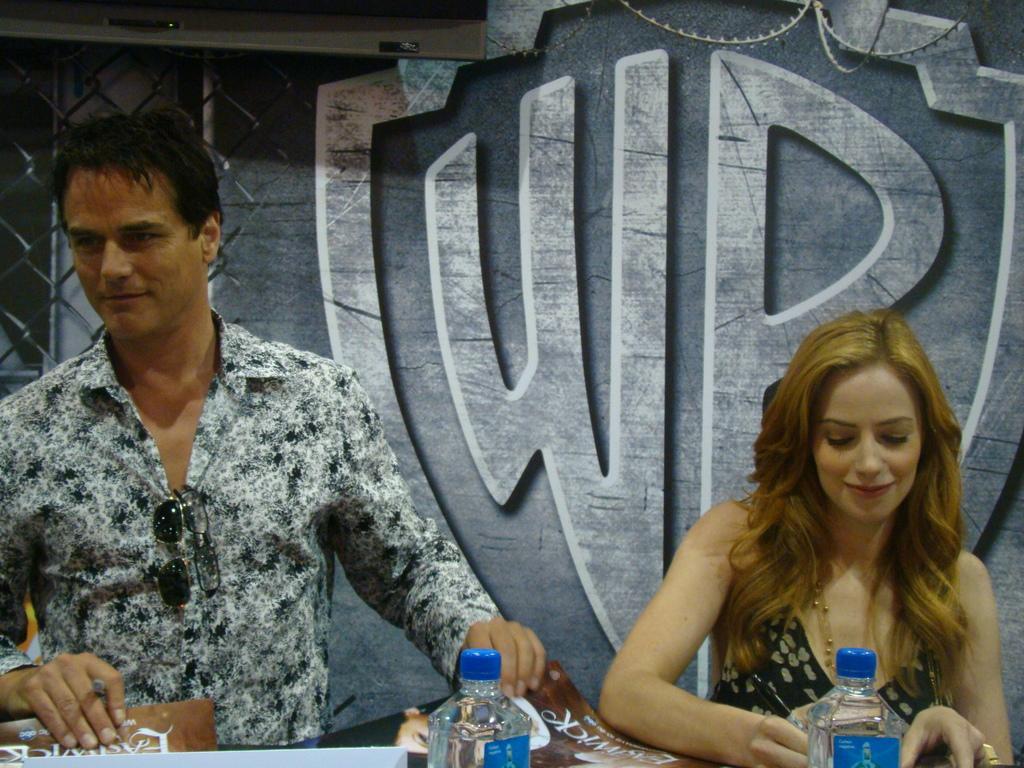Describe this image in one or two sentences. This image is clicked inside. There are two persons in this image. To the right, the woman is wearing black dress. To the left, the man is wearing white and black shirt. In the front, there is a table on which there are bottles and books. In the background, there is a wall and window. 